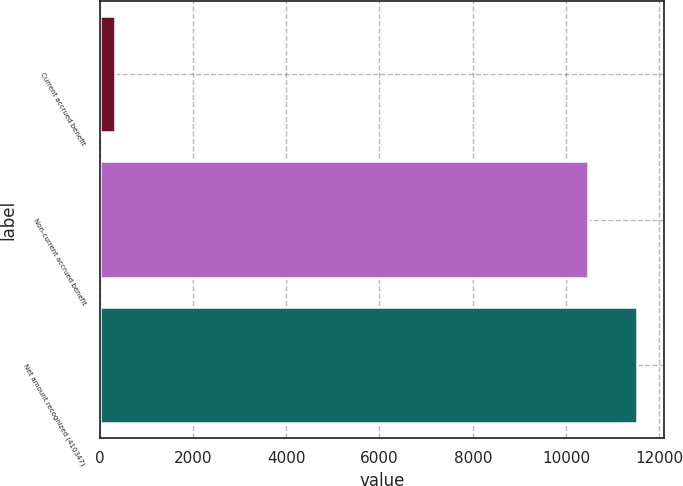<chart> <loc_0><loc_0><loc_500><loc_500><bar_chart><fcel>Current accrued benefit<fcel>Non-current accrued benefit<fcel>Net amount recognized (410347)<nl><fcel>336<fcel>10476<fcel>11523.6<nl></chart> 